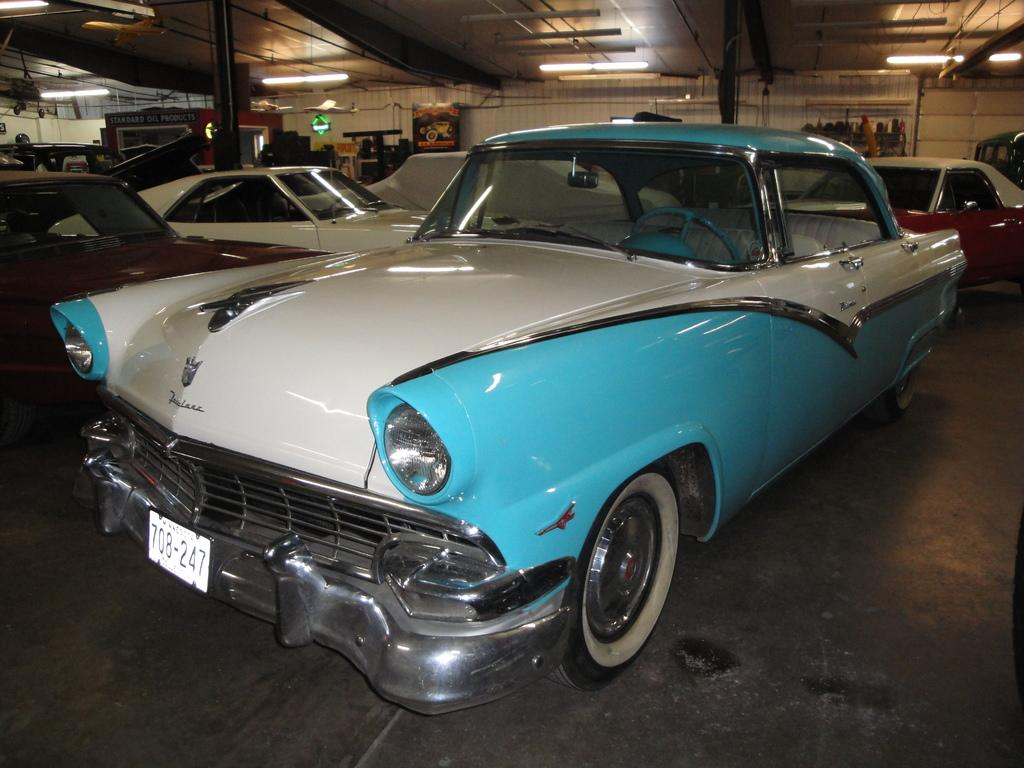What is the main subject in the foreground of the image? There is a car in the foreground of the image. Can you describe the position of the car in the image? The car is on the floor in the image. What can be seen in the background of the image? There are vehicles under a shed and lights visible in the background of the image. Are there any other objects present in the background of the image? Yes, there are objects present in the background of the image. What type of quartz can be seen on the car's dashboard in the image? There is no quartz visible on the car's dashboard in the image. How many legs does the car have in the image? Cars do not have legs; they have wheels. 